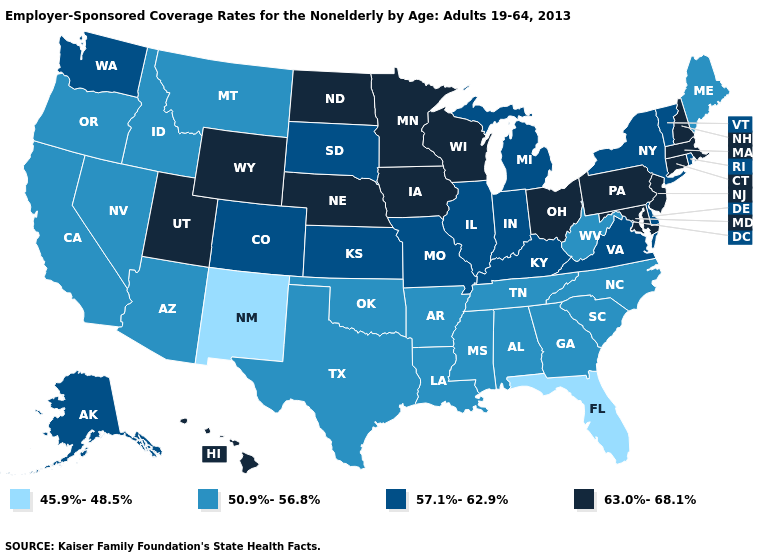Does the map have missing data?
Keep it brief. No. Among the states that border Wyoming , which have the highest value?
Write a very short answer. Nebraska, Utah. What is the value of Alaska?
Quick response, please. 57.1%-62.9%. Which states hav the highest value in the Northeast?
Keep it brief. Connecticut, Massachusetts, New Hampshire, New Jersey, Pennsylvania. What is the value of Montana?
Concise answer only. 50.9%-56.8%. Which states have the highest value in the USA?
Keep it brief. Connecticut, Hawaii, Iowa, Maryland, Massachusetts, Minnesota, Nebraska, New Hampshire, New Jersey, North Dakota, Ohio, Pennsylvania, Utah, Wisconsin, Wyoming. Does New Hampshire have the same value as Michigan?
Quick response, please. No. Name the states that have a value in the range 50.9%-56.8%?
Be succinct. Alabama, Arizona, Arkansas, California, Georgia, Idaho, Louisiana, Maine, Mississippi, Montana, Nevada, North Carolina, Oklahoma, Oregon, South Carolina, Tennessee, Texas, West Virginia. Does the map have missing data?
Give a very brief answer. No. What is the value of Alabama?
Give a very brief answer. 50.9%-56.8%. Among the states that border New York , which have the lowest value?
Concise answer only. Vermont. What is the value of Vermont?
Answer briefly. 57.1%-62.9%. Among the states that border Indiana , does Ohio have the highest value?
Short answer required. Yes. Does Nevada have the same value as Arizona?
Be succinct. Yes. Name the states that have a value in the range 63.0%-68.1%?
Concise answer only. Connecticut, Hawaii, Iowa, Maryland, Massachusetts, Minnesota, Nebraska, New Hampshire, New Jersey, North Dakota, Ohio, Pennsylvania, Utah, Wisconsin, Wyoming. 